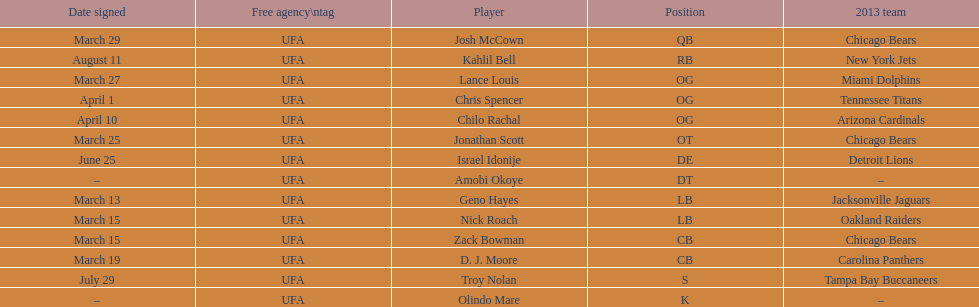The only player to sign in july? Troy Nolan. 